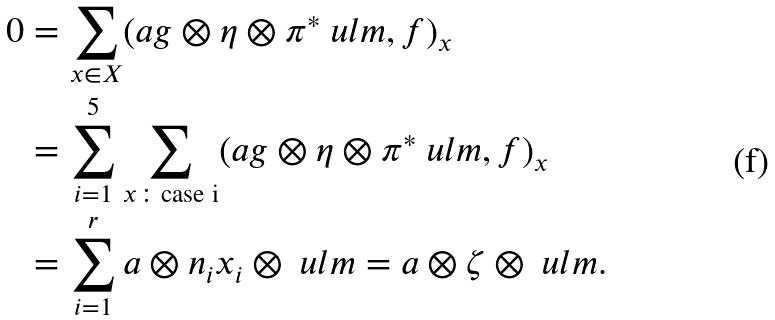<formula> <loc_0><loc_0><loc_500><loc_500>0 & = \sum _ { x \in X } ( a g \otimes \eta \otimes \pi ^ { * } \ u l { m } , f ) _ { x } \\ & = \sum _ { i = 1 } ^ { 5 } \sum _ { x \colon \text {case i} } ( a g \otimes \eta \otimes \pi ^ { * } \ u l { m } , f ) _ { x } \\ & = \sum _ { i = 1 } ^ { r } a \otimes n _ { i } x _ { i } \otimes \ u l { m } = a \otimes \zeta \otimes \ u l { m } .</formula> 